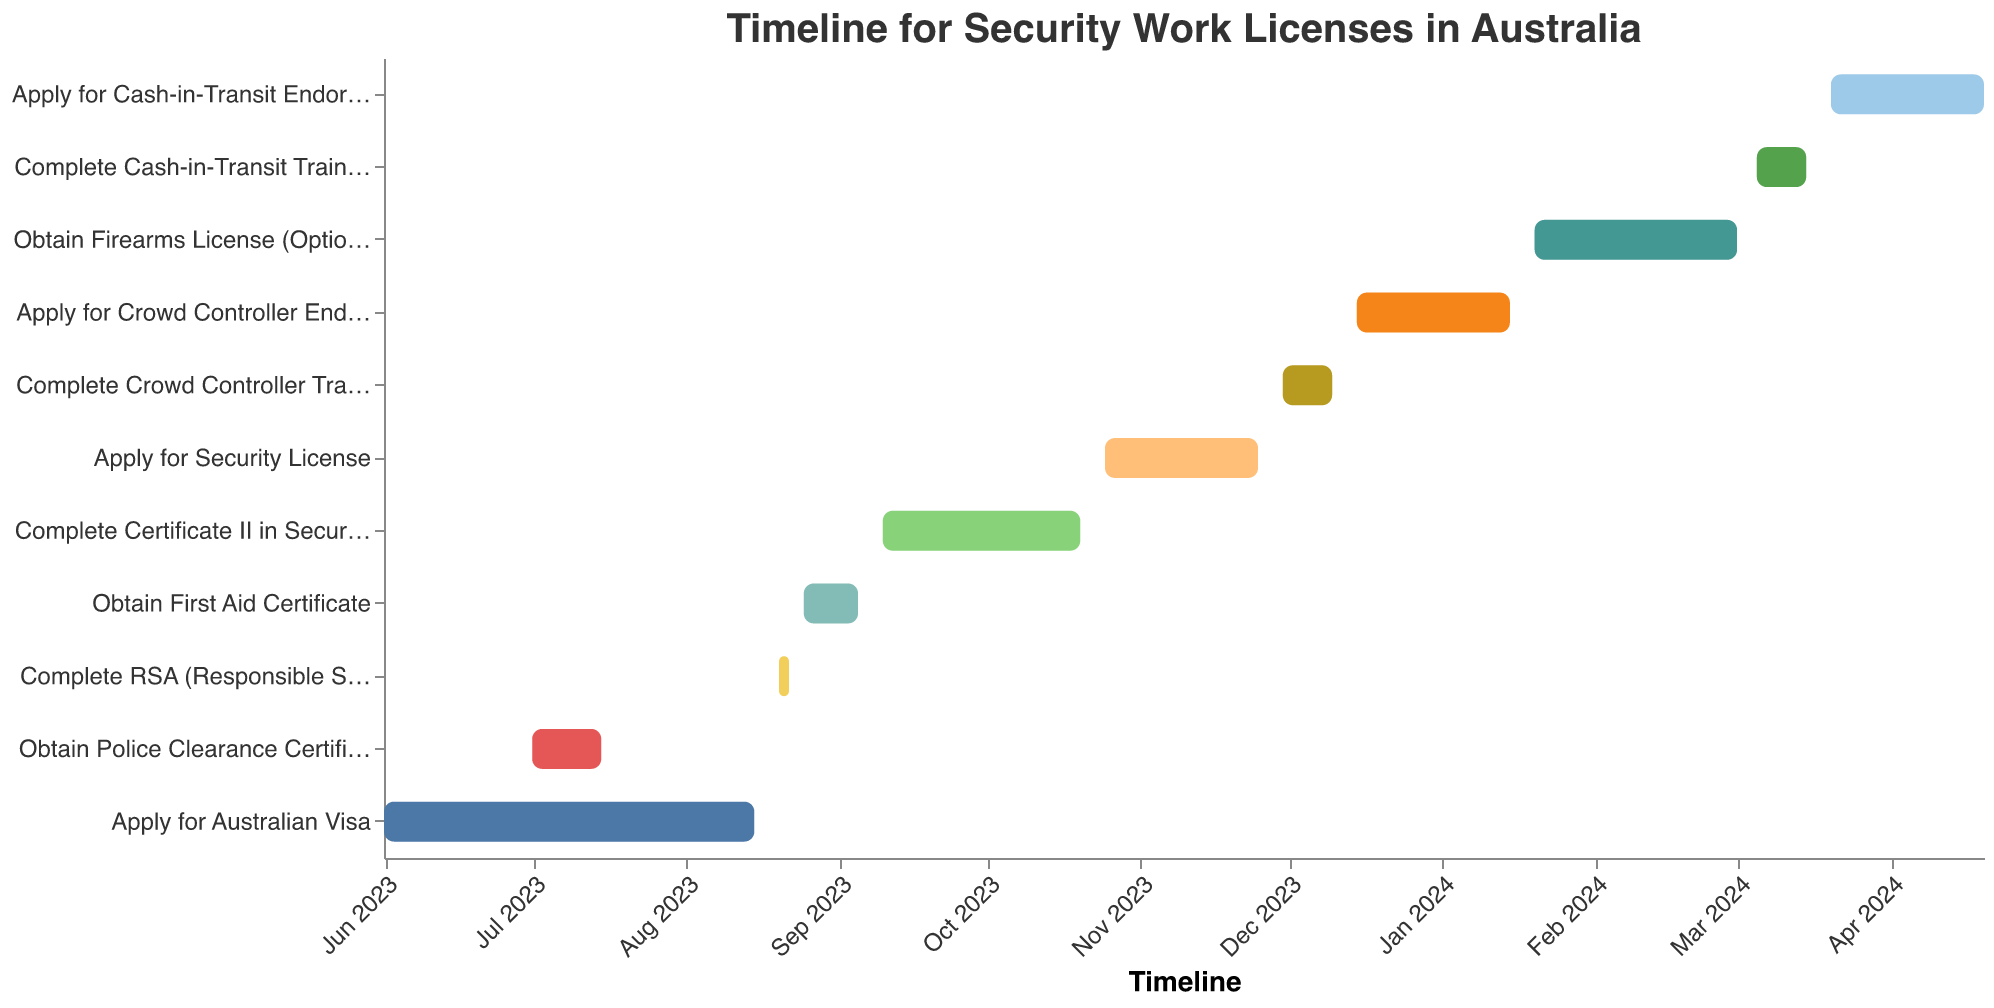What is the time frame for obtaining the Police Clearance Certificate? According to the figure, the task "Obtain Police Clearance Certificate" starts on July 1, 2023, and ends on July 15, 2023.
Answer: July 1, 2023 - July 15, 2023 How long does it take to complete the RSA (Responsible Service of Alcohol) Course? By examining the Gantt Chart, the task "Complete RSA (Responsible Service of Alcohol) Course" spans from August 20, 2023, to August 22, 2023, which is a total of 3 days.
Answer: 3 days Which task starts immediately after obtaining the First Aid Certificate? From the visual timeline, the task "Complete Certificate II in Security Operations" starts on September 10, 2023, immediately following the end date of "Obtain First Aid Certificate" on September 5, 2023.
Answer: Complete Certificate II in Security Operations Which two tasks overlap in their timelines? The tasks "Apply for Australian Visa" and "Obtain Police Clearance Certificate" both occur during July 1, 2023 - July 15, 2023 as seen in the Gantt Chart.
Answer: Apply for Australian Visa and Obtain Police Clearance Certificate How many days are there between completing the RSA Course and starting the First Aid Certificate? "Complete RSA (Responsible Service of Alcohol) Course" ends on August 22, 2023, and "Obtain First Aid Certificate" starts on August 25, 2023. There are 3 days between these two tasks.
Answer: 3 days What is the total duration for the process from applying for the Australian Visa to obtaining the Cash-in-Transit Endorsement? The process starts with "Apply for Australian Visa" on June 1, 2023, and ends with "Apply for Cash-in-Transit Endorsement" on April 20, 2024. Calculating the difference between these dates results in approximately 324 days.
Answer: 324 days What is the shortest task in the entire timeline? Reviewing the length of the tasks, "Complete RSA (Responsible Service of Alcohol) Course" spans from August 20, 2023, to August 22, 2023, making it the shortest task.
Answer: Complete RSA (Responsible Service of Alcohol) Course Which task spans across the new year into 2024? From the visual representation, "Apply for Crowd Controller Endorsement" starts on December 15, 2023, and ends on January 15, 2024, thus spanning the new year transition.
Answer: Apply for Crowd Controller Endorsement How many tasks are scheduled after the completion of the Certificate II in Security Operations? Counting all tasks starting after October 20, 2023 (the end date for Certificate II in Security Operations), there are a total of six tasks remaining.
Answer: 6 tasks 